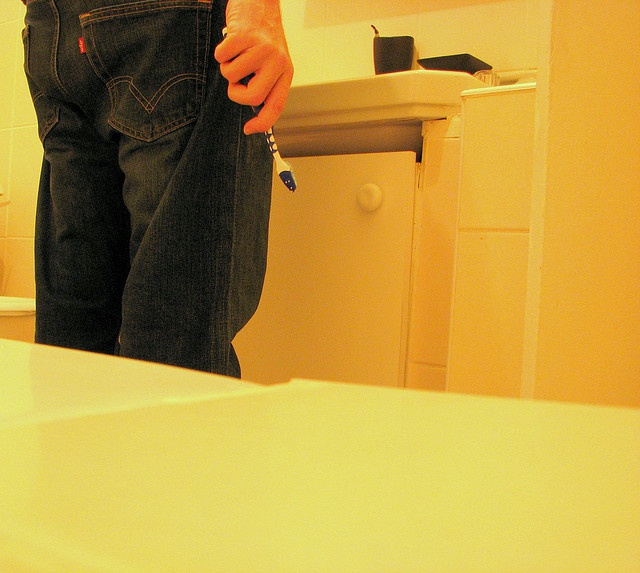Describe the objects in this image and their specific colors. I can see people in khaki, black, red, and gray tones, sink in khaki, brown, orange, and maroon tones, and toothbrush in khaki, orange, gold, black, and maroon tones in this image. 